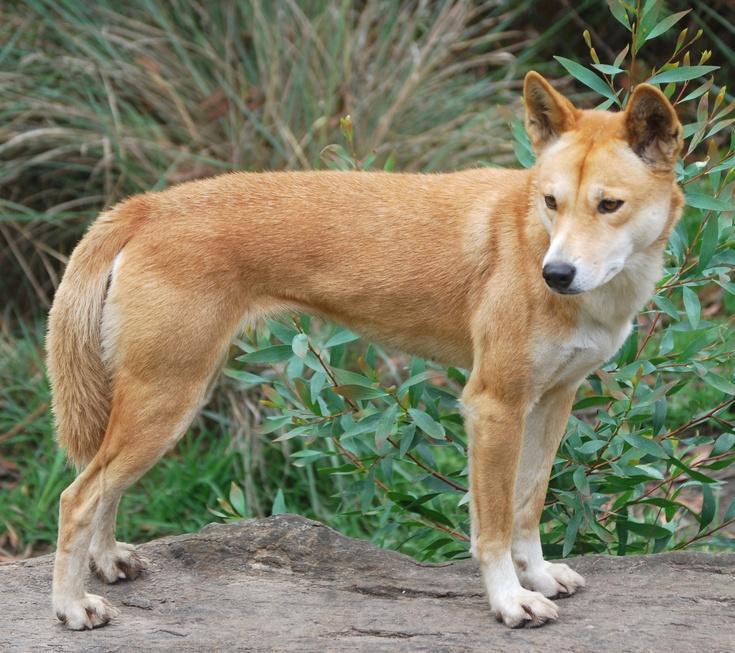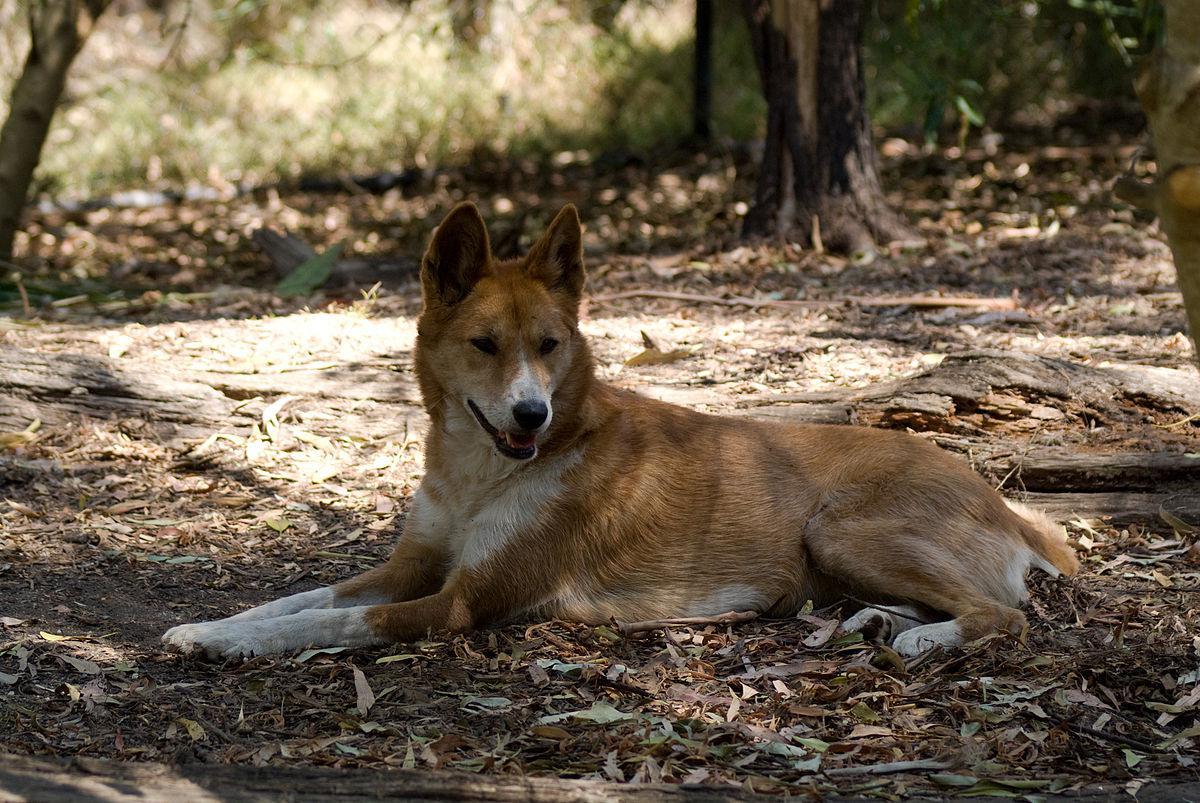The first image is the image on the left, the second image is the image on the right. Given the left and right images, does the statement "At least one animal is lying on the ground in the image on the right." hold true? Answer yes or no. Yes. 